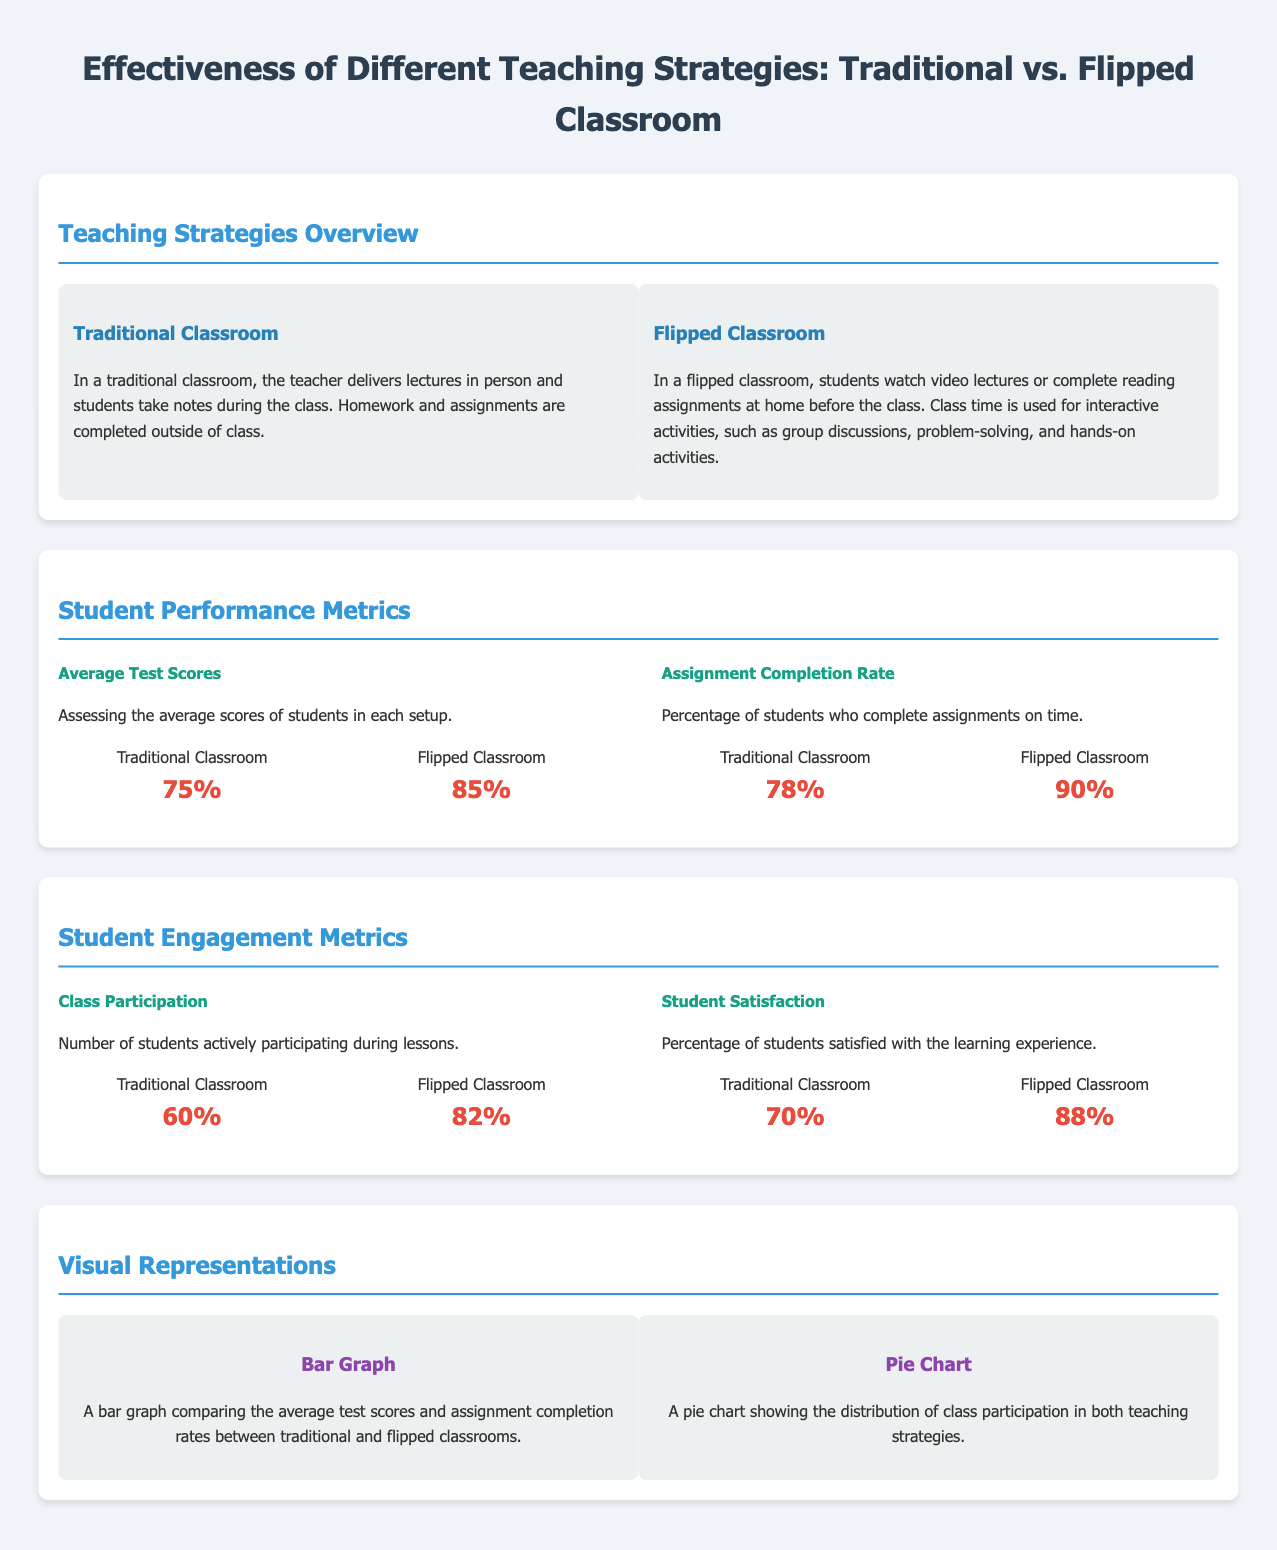What is the average test score in a Traditional Classroom? The average test score for students in a Traditional Classroom is mentioned in the document.
Answer: 75% What is the Assignment Completion Rate for Flipped Classroom? The percentage of students completing assignments on time in a Flipped Classroom is provided.
Answer: 90% Which teaching strategy has a higher student satisfaction rate? The document compares student satisfaction rates between the two strategies.
Answer: Flipped Classroom What is the Class Participation percentage in Traditional Classroom? The document states the percentage of students actively participating during lessons in Traditional Classroom.
Answer: 60% How much higher are the average test scores in the Flipped Classroom compared to Traditional Classroom? The difference in average test scores is calculated by comparing the scores from both classroom types.
Answer: 10% What percentage of students are satisfied with the learning experience in the Flipped Classroom? The document specifies the satisfaction percentage for students in the Flipped Classroom.
Answer: 88% Which metric shows an improvement in the Flipped Classroom compared to the Traditional Classroom? The document states various metrics, highlighting improvements in the Flipped Classroom.
Answer: All metrics What is the purpose of the visual representations in the document? The visual representations are included to illustrate comparisons of metrics outlined in the document.
Answer: Comparison How many metrics are presented in the Student Engagement section? The number of metrics in the Student Engagement section can be counted from the document.
Answer: Two 